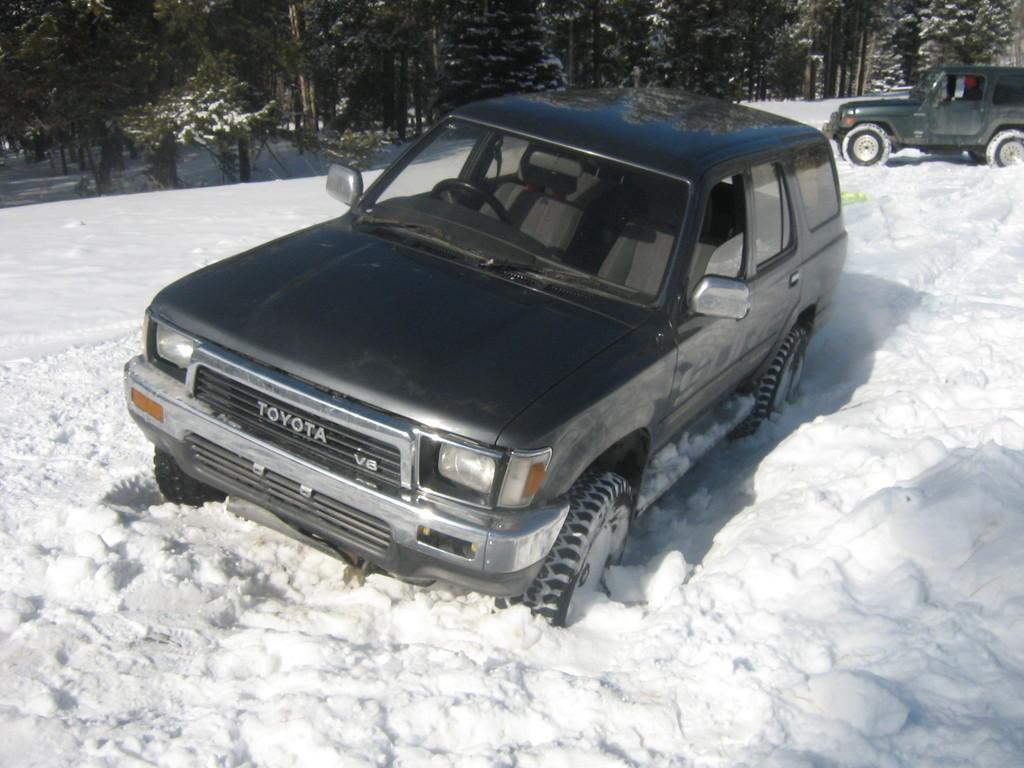Could you give a brief overview of what you see in this image? In this image there are vehicles on the land which is covered with the snow. Background there are trees. 